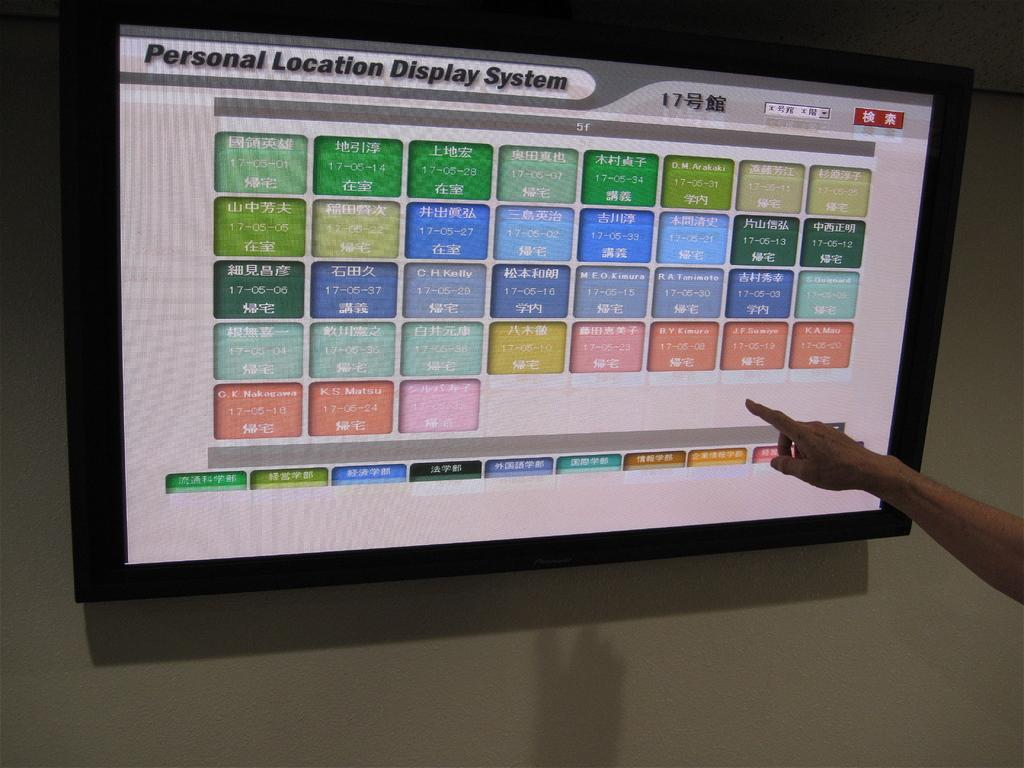Provide a one-sentence caption for the provided image. a monitor reading Personal Location Display System and a hand pointing at it. 